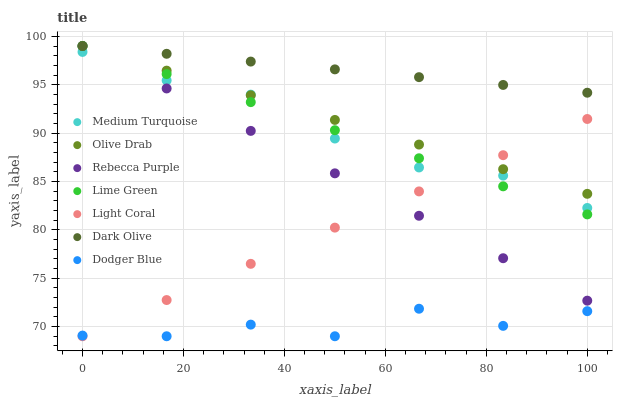Does Dodger Blue have the minimum area under the curve?
Answer yes or no. Yes. Does Dark Olive have the maximum area under the curve?
Answer yes or no. Yes. Does Light Coral have the minimum area under the curve?
Answer yes or no. No. Does Light Coral have the maximum area under the curve?
Answer yes or no. No. Is Light Coral the smoothest?
Answer yes or no. Yes. Is Dodger Blue the roughest?
Answer yes or no. Yes. Is Dodger Blue the smoothest?
Answer yes or no. No. Is Light Coral the roughest?
Answer yes or no. No. Does Light Coral have the lowest value?
Answer yes or no. Yes. Does Rebecca Purple have the lowest value?
Answer yes or no. No. Does Olive Drab have the highest value?
Answer yes or no. Yes. Does Light Coral have the highest value?
Answer yes or no. No. Is Dodger Blue less than Dark Olive?
Answer yes or no. Yes. Is Lime Green greater than Dodger Blue?
Answer yes or no. Yes. Does Light Coral intersect Dodger Blue?
Answer yes or no. Yes. Is Light Coral less than Dodger Blue?
Answer yes or no. No. Is Light Coral greater than Dodger Blue?
Answer yes or no. No. Does Dodger Blue intersect Dark Olive?
Answer yes or no. No. 